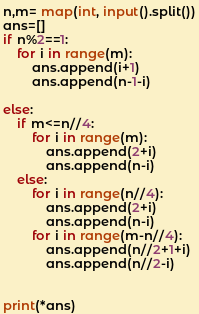<code> <loc_0><loc_0><loc_500><loc_500><_Python_>n,m= map(int, input().split())
ans=[]
if n%2==1:
    for i in range(m):
        ans.append(i+1)
        ans.append(n-1-i)

else:
    if m<=n//4:
        for i in range(m):
            ans.append(2+i)
            ans.append(n-i)
    else:
        for i in range(n//4):
            ans.append(2+i)
            ans.append(n-i)
        for i in range(m-n//4):
            ans.append(n//2+1+i)
            ans.append(n//2-i)


print(*ans)</code> 